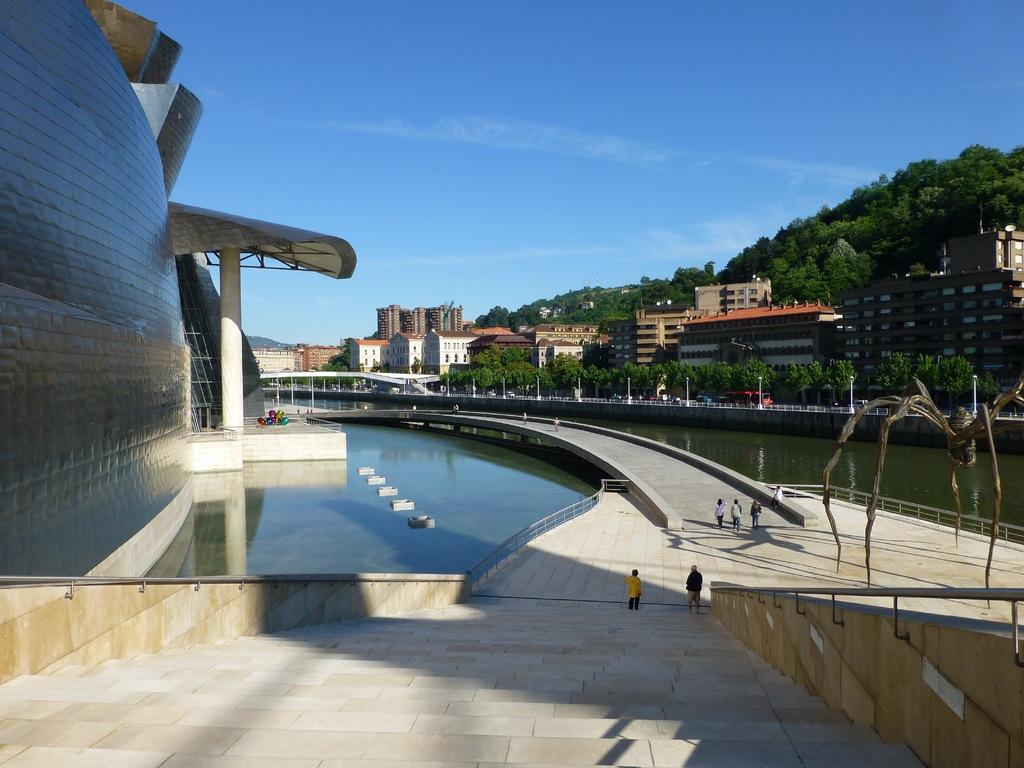What type of structures can be seen in the image? There are buildings in the image. What natural elements are present in the image? There are trees in the image. What type of man-made objects can be seen in the image? There are light poles in the image. What architectural feature is present in the image? There is a railing in the image. What type of infrastructure is visible in the image? There is a bridge in the image. What type of pathway is present in the image? There are stairs in the image. Are there any living beings in the image? Yes, there are people in the image. What is visible in the background of the image? The sky is visible in the image. How many pears are being held by the governor in the image? There is no governor or pear present in the image. What type of dust can be seen settling on the buildings in the image? There is no dust present in the image; the buildings appear clean. 